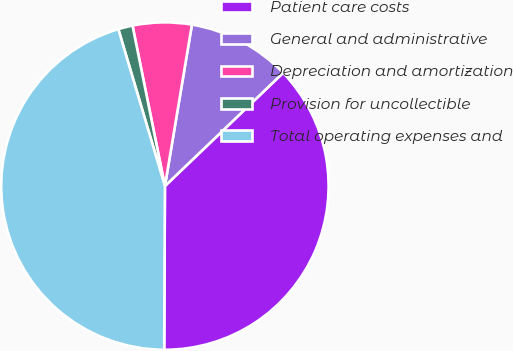Convert chart. <chart><loc_0><loc_0><loc_500><loc_500><pie_chart><fcel>Patient care costs<fcel>General and administrative<fcel>Depreciation and amortization<fcel>Provision for uncollectible<fcel>Total operating expenses and<nl><fcel>37.22%<fcel>10.2%<fcel>5.81%<fcel>1.42%<fcel>45.33%<nl></chart> 